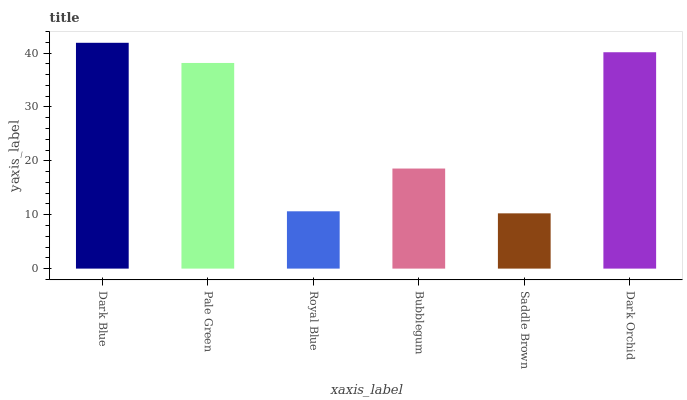Is Saddle Brown the minimum?
Answer yes or no. Yes. Is Dark Blue the maximum?
Answer yes or no. Yes. Is Pale Green the minimum?
Answer yes or no. No. Is Pale Green the maximum?
Answer yes or no. No. Is Dark Blue greater than Pale Green?
Answer yes or no. Yes. Is Pale Green less than Dark Blue?
Answer yes or no. Yes. Is Pale Green greater than Dark Blue?
Answer yes or no. No. Is Dark Blue less than Pale Green?
Answer yes or no. No. Is Pale Green the high median?
Answer yes or no. Yes. Is Bubblegum the low median?
Answer yes or no. Yes. Is Bubblegum the high median?
Answer yes or no. No. Is Royal Blue the low median?
Answer yes or no. No. 